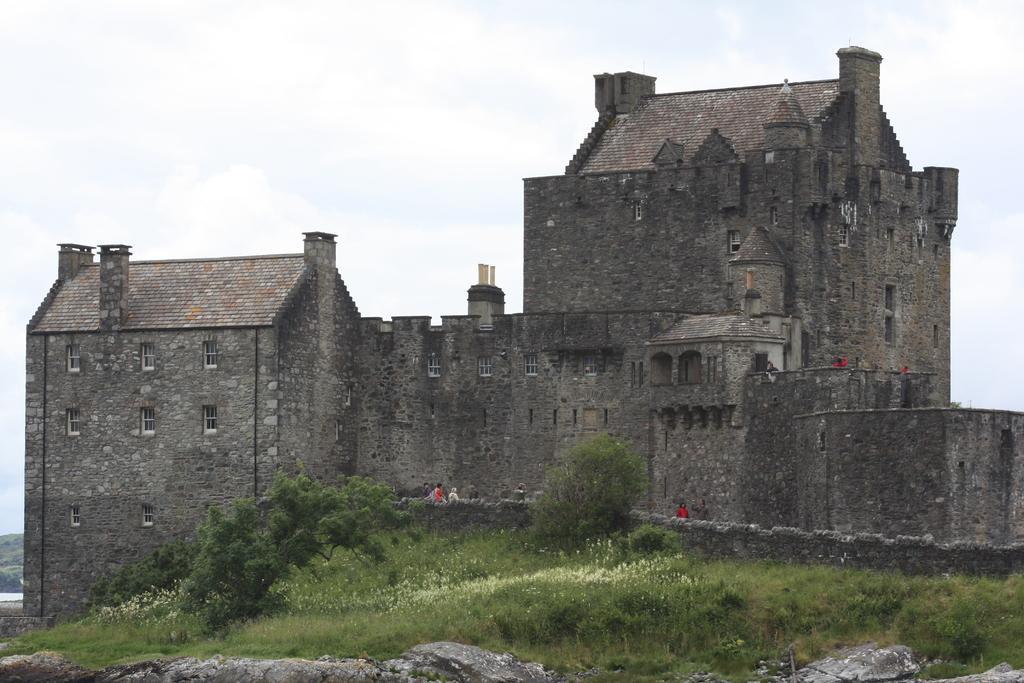In one or two sentences, can you explain what this image depicts? This image consists of a building along with windows. At the bottom, we can see rocks, plants and green grass. And there are few persons in this image. At the top, there are clouds in the sky. 